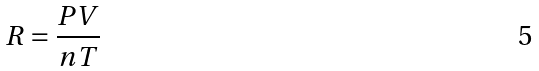<formula> <loc_0><loc_0><loc_500><loc_500>R = { \frac { P V } { n T } }</formula> 